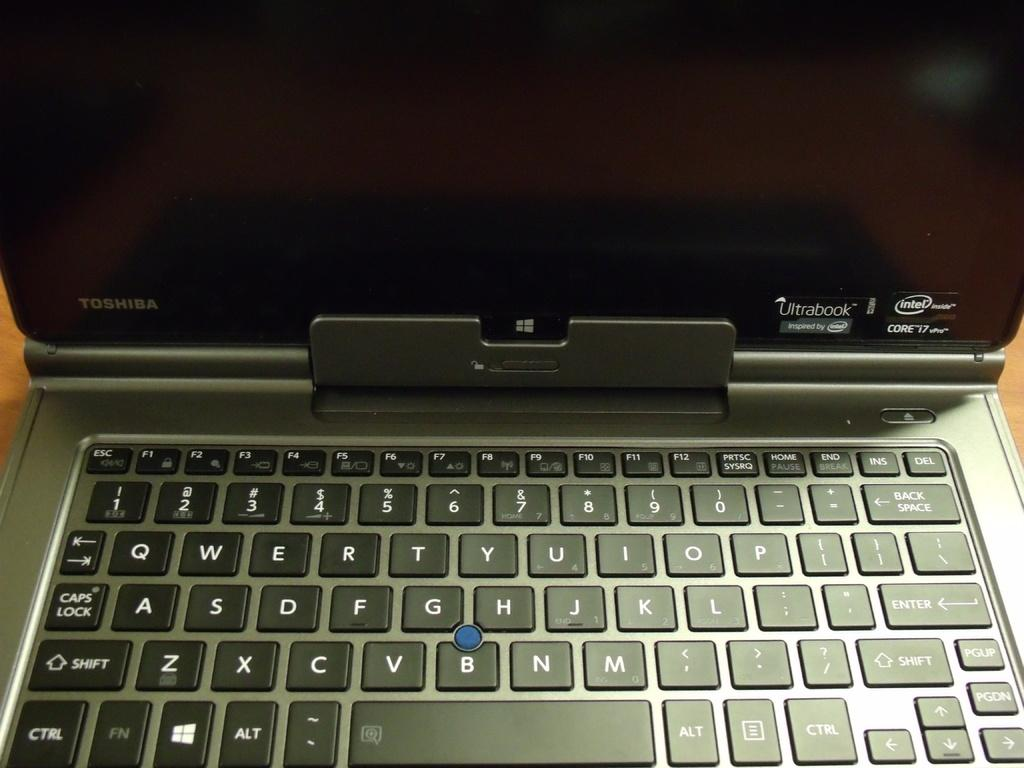<image>
Offer a succinct explanation of the picture presented. An open toshiba laptop with an intel processor. 